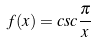<formula> <loc_0><loc_0><loc_500><loc_500>f ( x ) = c s c \frac { \pi } { x }</formula> 